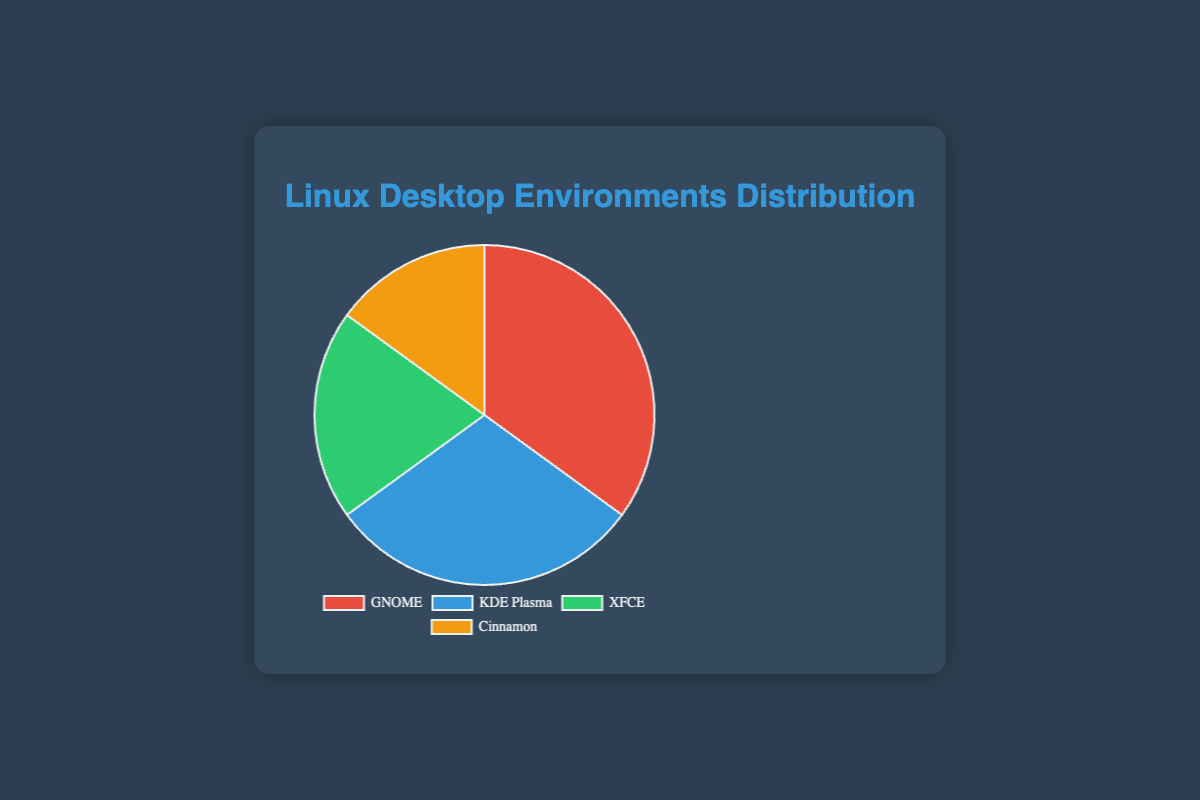What percentage of Linux users prefer GNOME over Cinnamon? GNOME has 35% of the users and Cinnamon has 15%, so GNOME has 35% - 15% = 20% more users than Cinnamon.
Answer: 20% Which desktop environment is the second most popular? From the chart, the order of preferences by percentage is GNOME (35%), KDE Plasma (30%), XFCE (20%), and Cinnamon (15%). KDE Plasma is second.
Answer: KDE Plasma If the total number of users surveyed was 1000, how many use XFCE? XFCE has 20% of users. If there are 1000 users, 20% of 1000 is 0.20 * 1000 = 200 users use XFCE.
Answer: 200 What is the combined percentage of users for KDE Plasma and XFCE? KDE Plasma has 30% and XFCE has 20%, so the combined percentage is 30% + 20% = 50%.
Answer: 50% How does the user base of Cinnamon compare to the combined user base of KDE Plasma and XFCE? Cinnamon has 15%, while KDE Plasma and XFCE combined have 30% + 20% = 50%. 50% - 15% = 35% more users prefer KDE Plasma and XFCE combined.
Answer: 35% more What proportion of users prefer KDE Plasma over GNOME visually represented by the color? KDE Plasma (blue) has 30%, which is less than GNOME (red) with 35%.
Answer: KDE Plasma has 5% less If we grouped KDE Plasma and Cinnamon together, what would be their total percentage, and how would it compare to GNOME? KDE Plasma (30%) and Cinnamon (15%) combined give 30% + 15% = 45%. GNOME has 35%. 45% - 35% = 10% more.
Answer: 10% more Which color represents the least popular desktop environment, and what is its percentage? The least popular desktop environment is represented by the orange color, which is Cinnamon at 15%.
Answer: Orange, 15% 